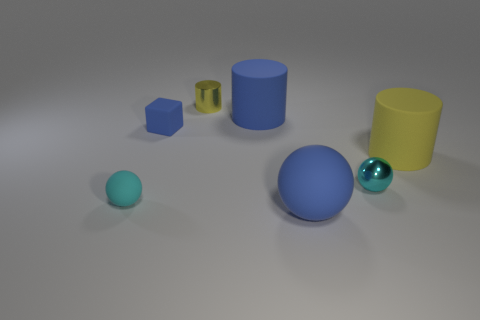Does the cube have the same color as the big sphere?
Provide a short and direct response. Yes. The yellow metal object that is the same shape as the yellow matte thing is what size?
Your answer should be very brief. Small. What number of blue things have the same material as the blue ball?
Provide a short and direct response. 2. Do the yellow cylinder right of the large blue sphere and the tiny yellow cylinder have the same material?
Your answer should be compact. No. Are there an equal number of cyan rubber things that are in front of the blue matte ball and red rubber cubes?
Ensure brevity in your answer.  Yes. The blue matte block is what size?
Give a very brief answer. Small. There is another cylinder that is the same color as the metallic cylinder; what material is it?
Give a very brief answer. Rubber. How many tiny rubber things have the same color as the shiny sphere?
Offer a very short reply. 1. Do the block and the shiny ball have the same size?
Provide a succinct answer. Yes. How big is the blue matte block that is to the left of the rubber object on the right side of the small cyan metallic thing?
Offer a terse response. Small. 